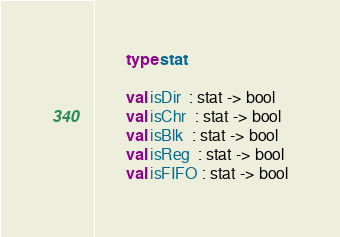<code> <loc_0><loc_0><loc_500><loc_500><_SML_>        type stat
            
        val isDir  : stat -> bool
        val isChr  : stat -> bool
        val isBlk  : stat -> bool
        val isReg  : stat -> bool
        val isFIFO : stat -> bool</code> 